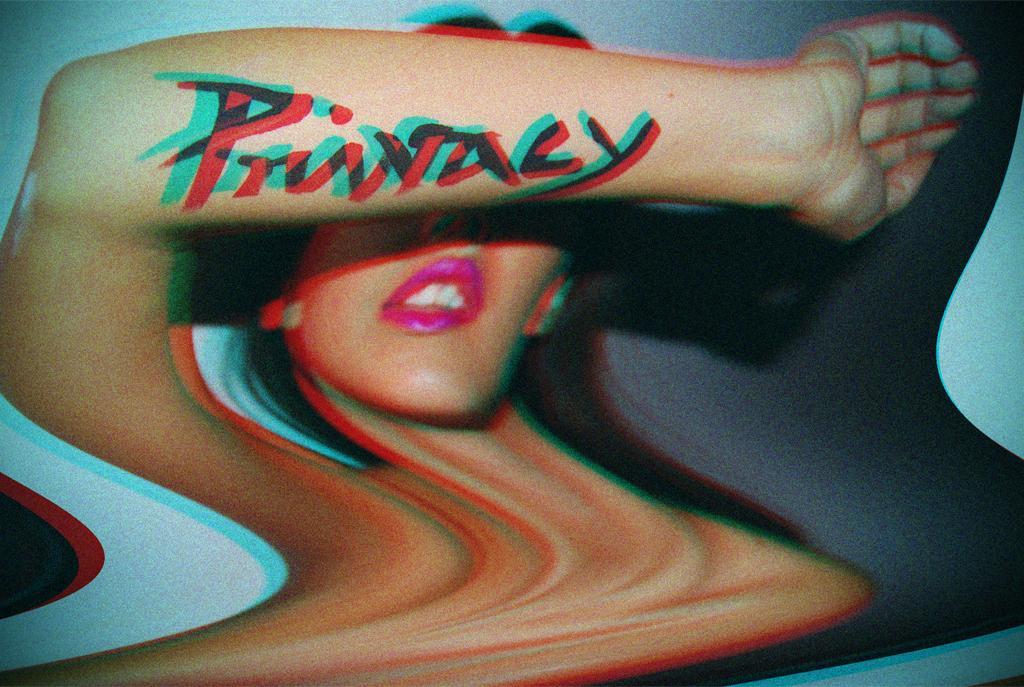Describe this image in one or two sentences. In this image we can see an edited picture of a woman with text on her hand and a blue colored background. 